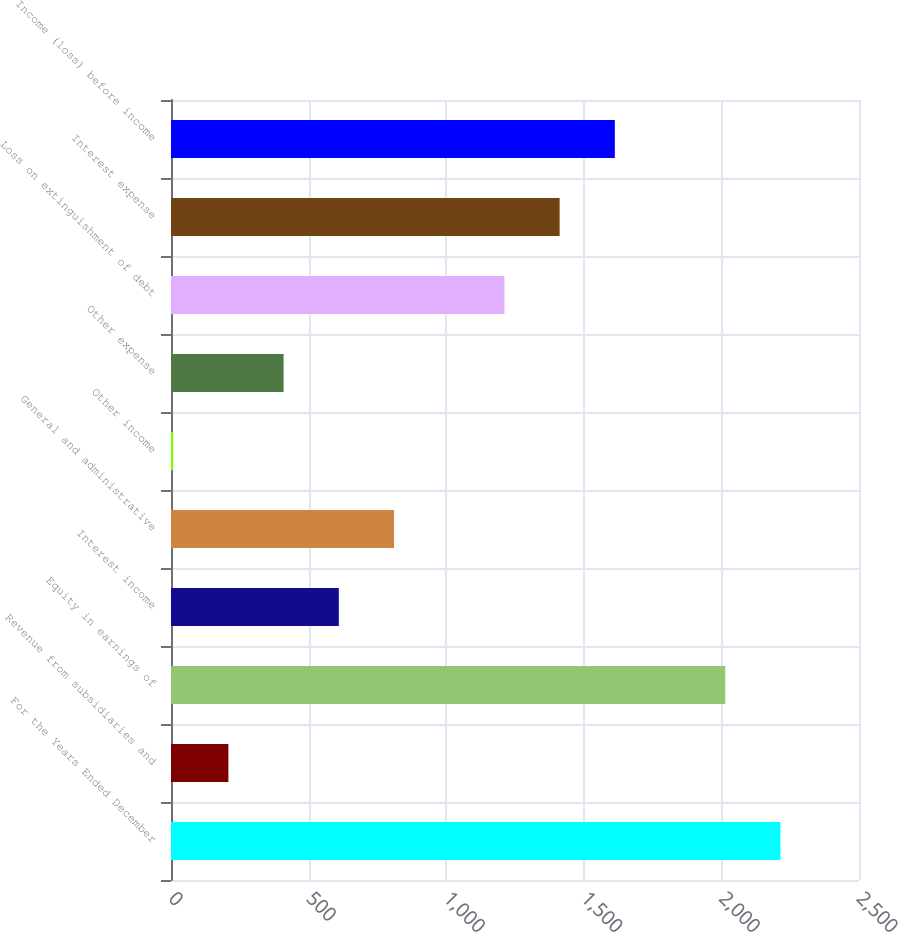<chart> <loc_0><loc_0><loc_500><loc_500><bar_chart><fcel>For the Years Ended December<fcel>Revenue from subsidiaries and<fcel>Equity in earnings of<fcel>Interest income<fcel>General and administrative<fcel>Other income<fcel>Other expense<fcel>Loss on extinguishment of debt<fcel>Interest expense<fcel>Income (loss) before income<nl><fcel>2214.6<fcel>208.6<fcel>2014<fcel>609.8<fcel>810.4<fcel>8<fcel>409.2<fcel>1211.6<fcel>1412.2<fcel>1612.8<nl></chart> 